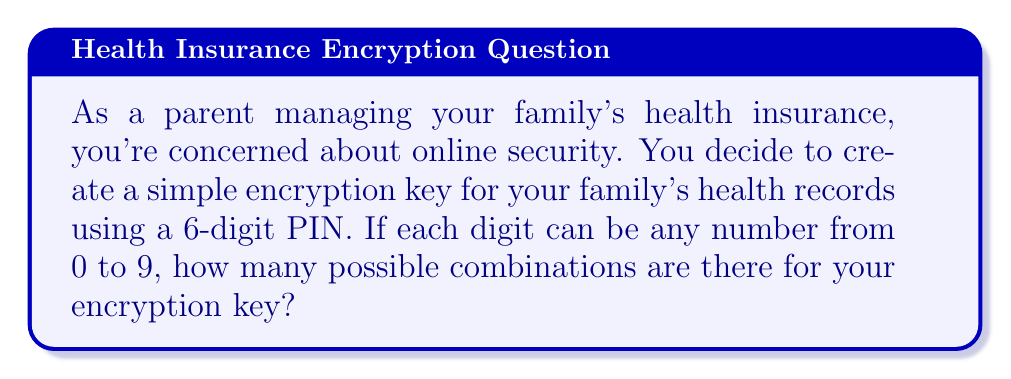Solve this math problem. To solve this problem, we'll use the fundamental counting principle. Here's a step-by-step explanation:

1) Each digit in the PIN can be any number from 0 to 9, which means there are 10 choices for each digit.

2) The PIN has 6 digits, and each digit's choice is independent of the others.

3) According to the fundamental counting principle, when we have a series of independent choices, we multiply the number of possibilities for each choice.

4) In this case, we have 10 choices for each of the 6 digits.

5) Therefore, the total number of possible combinations is:

   $$10 \times 10 \times 10 \times 10 \times 10 \times 10 = 10^6$$

6) We can calculate this:

   $$10^6 = 1,000,000$$

Thus, there are 1,000,000 possible combinations for your 6-digit PIN encryption key.
Answer: 1,000,000 